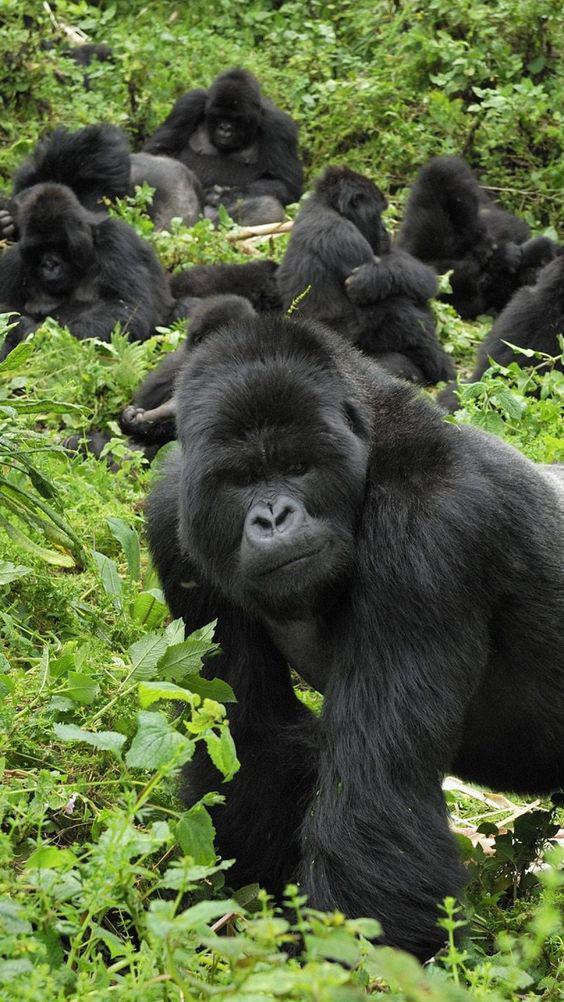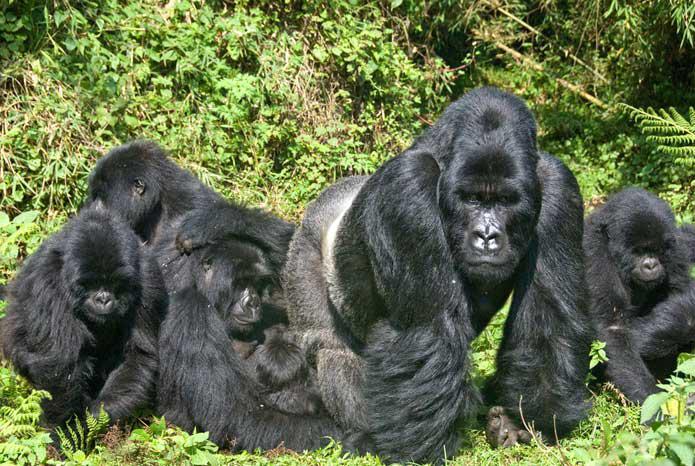The first image is the image on the left, the second image is the image on the right. For the images displayed, is the sentence "In each image, the gorilla closest to the camera is on all fours." factually correct? Answer yes or no. Yes. The first image is the image on the left, the second image is the image on the right. Considering the images on both sides, is "The left image contains exactly four gorillas." valid? Answer yes or no. No. 